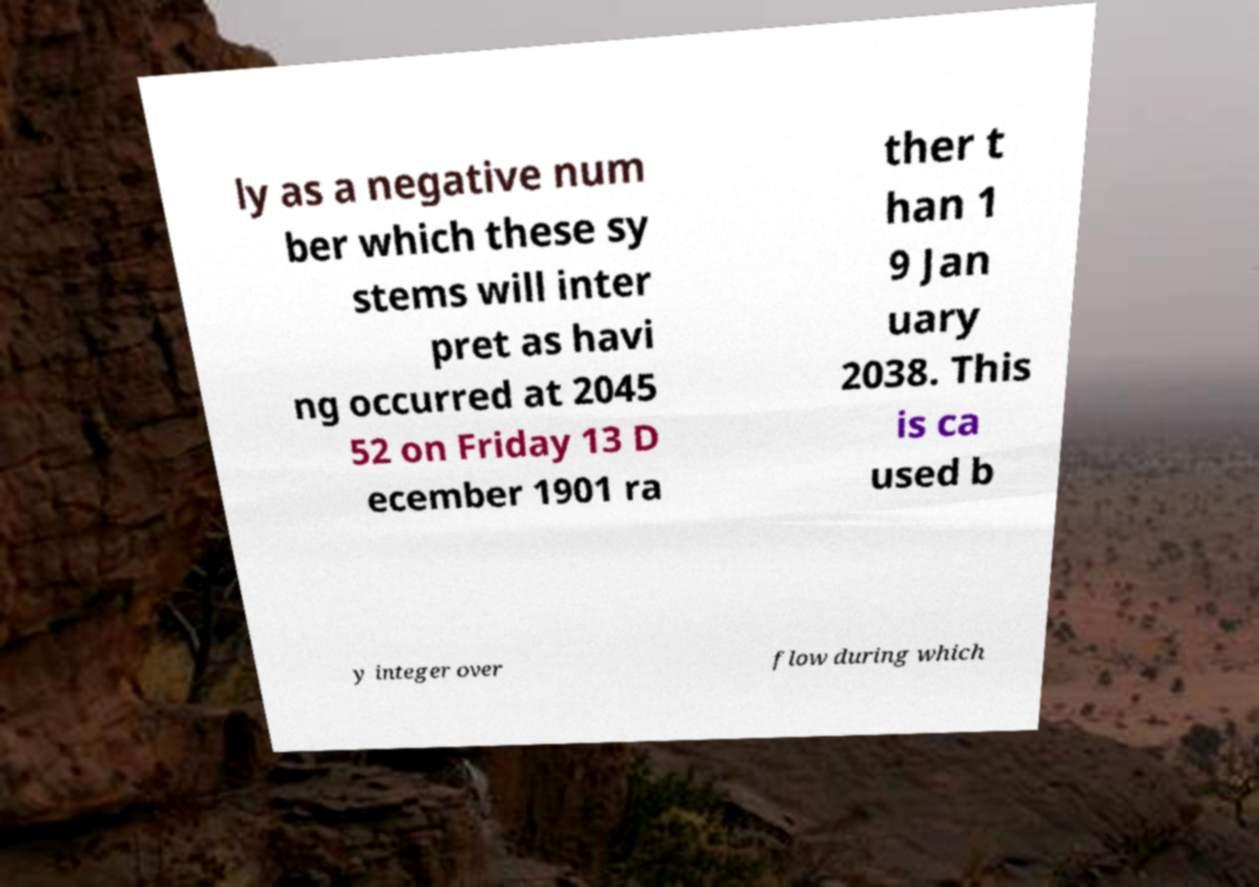Could you assist in decoding the text presented in this image and type it out clearly? ly as a negative num ber which these sy stems will inter pret as havi ng occurred at 2045 52 on Friday 13 D ecember 1901 ra ther t han 1 9 Jan uary 2038. This is ca used b y integer over flow during which 